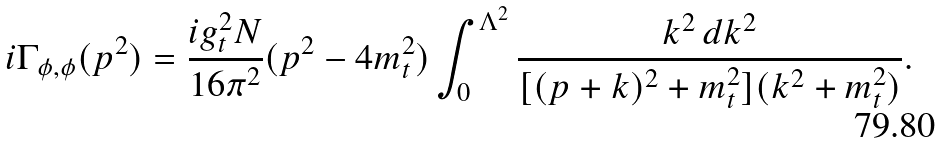Convert formula to latex. <formula><loc_0><loc_0><loc_500><loc_500>i \Gamma _ { \phi , \phi } ( p ^ { 2 } ) = \frac { i g _ { t } ^ { 2 } N } { 1 6 \pi ^ { 2 } } ( p ^ { 2 } - 4 m _ { t } ^ { 2 } ) \int _ { 0 } ^ { \Lambda ^ { 2 } } \frac { k ^ { 2 } \, d k ^ { 2 } } { [ ( p + k ) ^ { 2 } + m _ { t } ^ { 2 } ] ( k ^ { 2 } + m _ { t } ^ { 2 } ) } .</formula> 